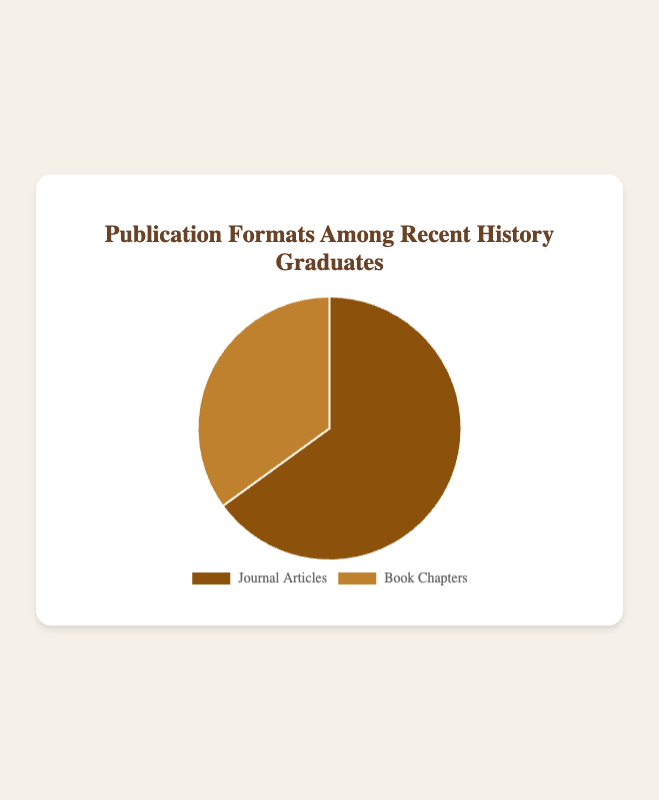What percentage of publications are journal articles? The figure shows that the percentage of journal articles among recent history graduates is 65%.
Answer: 65% How many times larger is the percentage of journal articles compared to book chapters? The percentage of journal articles is 65% and the percentage of book chapters is 35%. To find how many times larger, you divide 65 by 35.
Answer: 1.86 What is the combined percentage of journal articles and book chapters? The chart depicts two publication formats: journal articles at 65% and book chapters at 35%. Summing these percentages gives the combined percentage: 65 + 35 = 100.
Answer: 100% Which publication format is more prevalent among recent history graduates? The chart indicates that the percentage for journal articles is higher (65%) compared to book chapters (35%).
Answer: Journal Articles What is the difference in percentage points between journal articles and book chapters? The percentage for journal articles is 65% while for book chapters it is 35%. The difference is found by subtracting 35 from 65.
Answer: 30 If 200 publications were analyzed, how many would be journal articles? The total percentage for journal articles is 65%. For 200 publications, multiply 200 by 0.65 to find the number: 200 * 0.65 = 130
Answer: 130 What color represents journal articles in the chart? The chart displays journal articles in a brown-like color, distinct from the color used for book chapters.
Answer: Brown Which segment is larger in the pie chart, and by what ratio? The pie chart has two segments: journal articles at 65% and book chapters at 35%. The ratio of journal articles to book chapters is 65:35, which simplifies to approximately 1.86:1.
Answer: Journal Articles by 1.86:1 What fraction of the total publications are book chapters? To find the fraction of book chapters, use the percentage given (35%) and convert it to a fraction: 35% = 35/100 = 7/20.
Answer: 7/20 